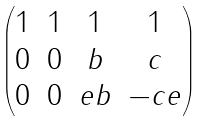Convert formula to latex. <formula><loc_0><loc_0><loc_500><loc_500>\begin{pmatrix} 1 & 1 & 1 & 1 \\ 0 & 0 & b & c \\ 0 & 0 & e b & - c e \end{pmatrix}</formula> 